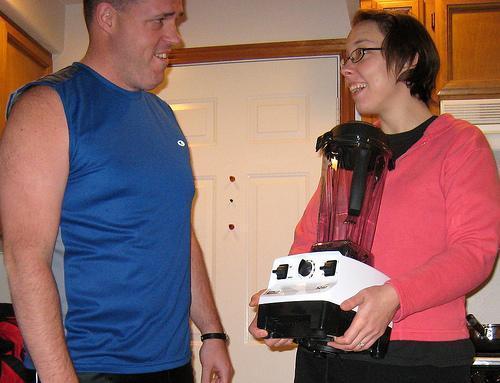How many people are in the picture?
Give a very brief answer. 2. How many men are in the picture?
Give a very brief answer. 1. 